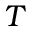Convert formula to latex. <formula><loc_0><loc_0><loc_500><loc_500>T</formula> 